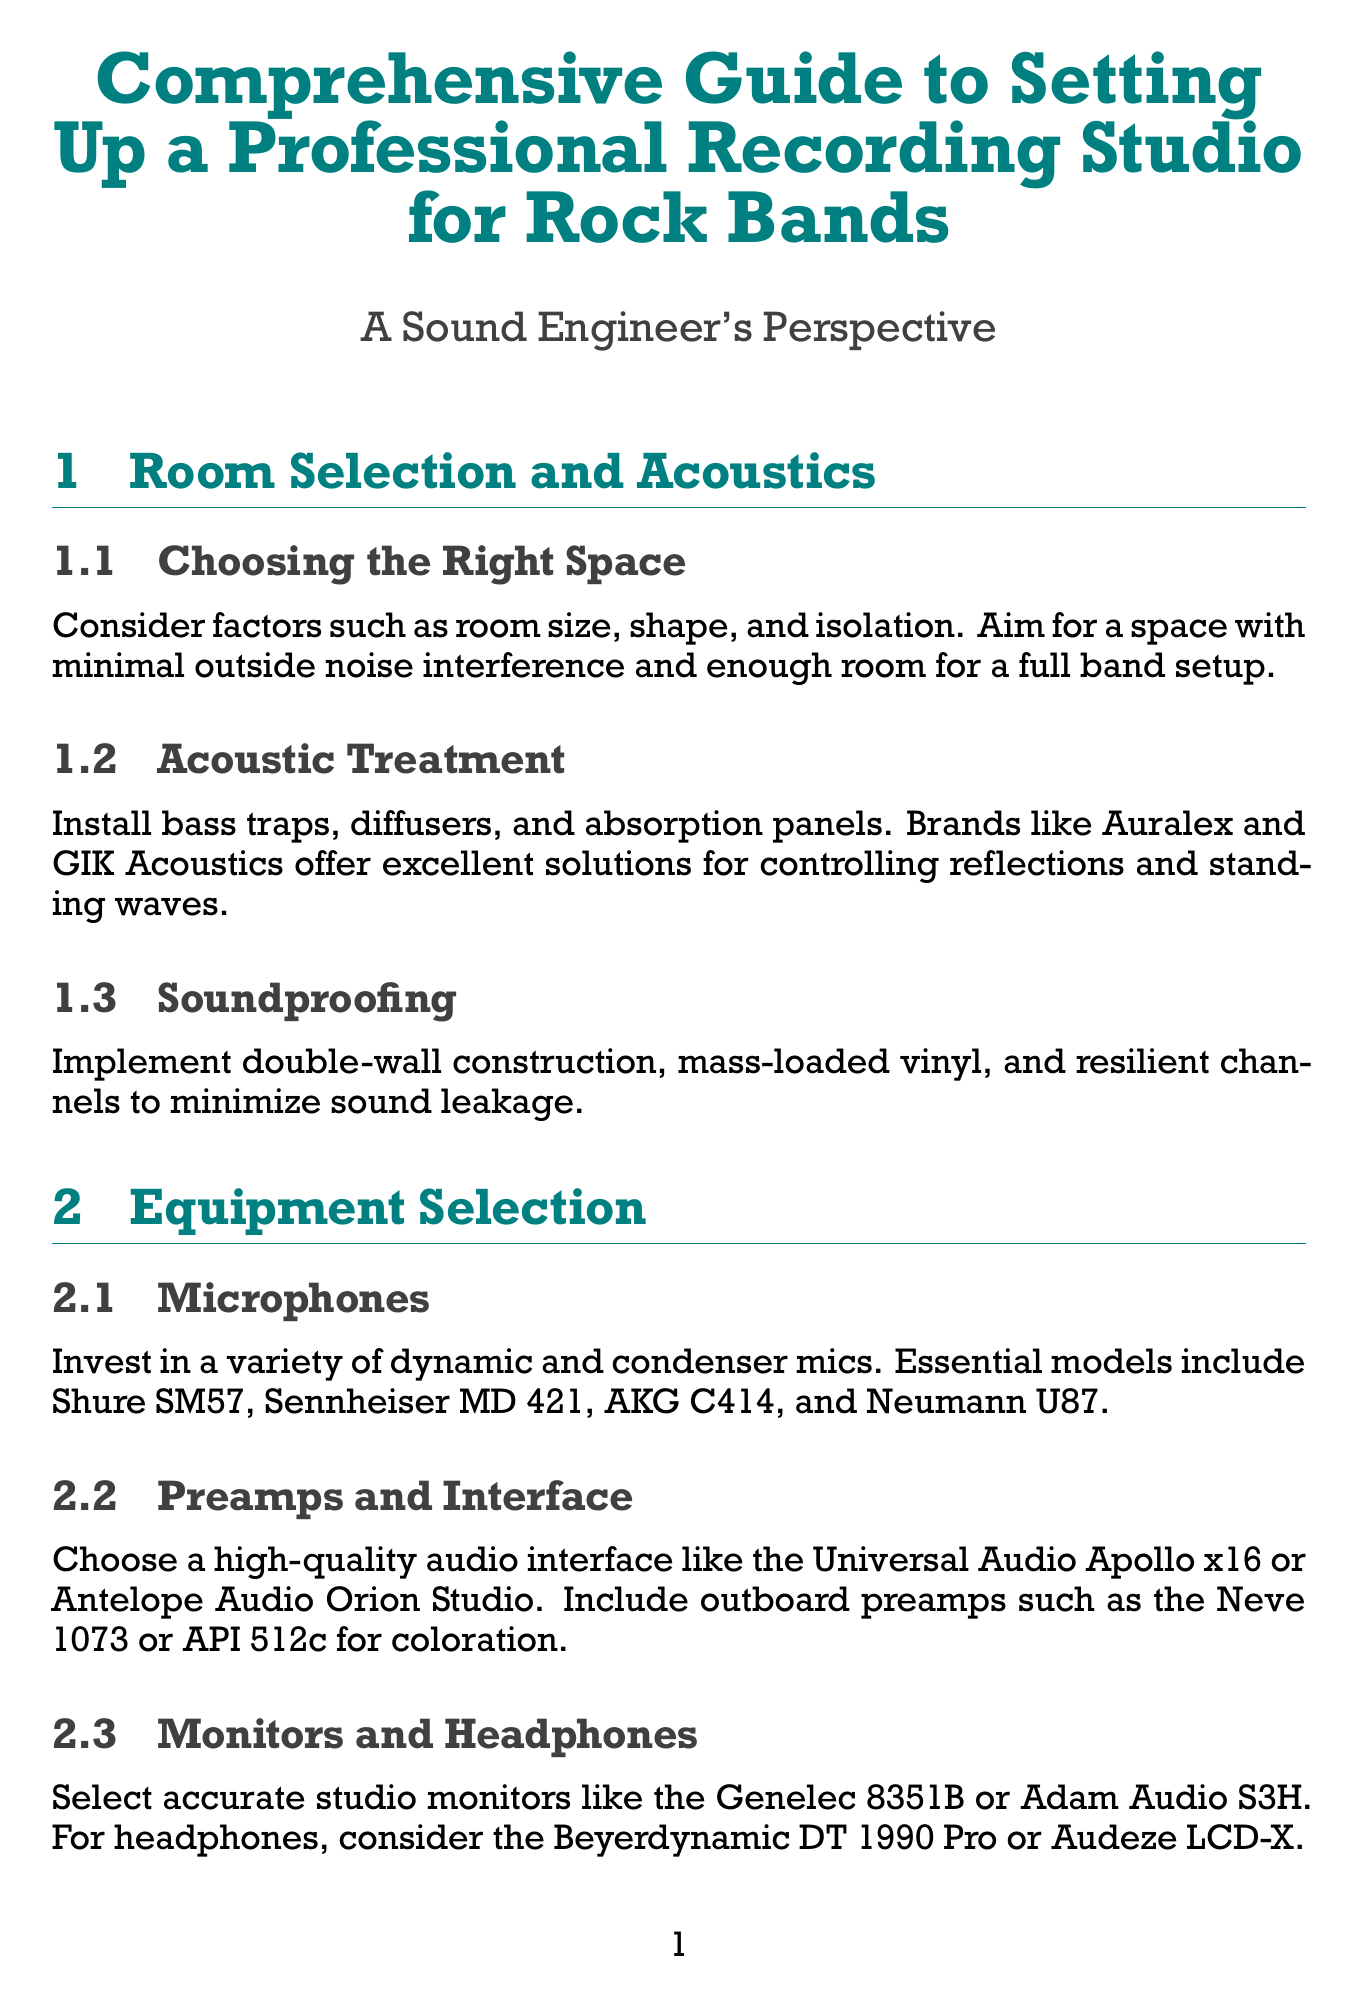What should be considered when choosing a recording space? The document mentions room size, shape, and isolation as key factors to consider for a recording space.
Answer: Room size, shape, and isolation Which microphones are essential for recording? The document lists essential microphones as Shure SM57, Sennheiser MD 421, AKG C414, and Neumann U87.
Answer: Shure SM57, Sennheiser MD 421, AKG C414, Neumann U87 What is recommended for acoustic treatment? The document advises installing bass traps, diffusers, and absorption panels for acoustic treatment.
Answer: Bass traps, diffusers, absorption panels Which DAWs are suggested for recording and editing? The document suggests Pro Tools, Logic Pro X, and Ableton Live as professional DAWs for recording and editing.
Answer: Pro Tools, Logic Pro X, Ableton Live What type of analog equipment is mentioned for achieving rock sound? The document references tape machines, analog compressors, and guitar and bass amplifiers for achieving rock sound.
Answer: Tape machines, analog compressors, guitar and bass amplifiers How can sound leakage be minimized? The document recommends implementing double-wall construction, mass-loaded vinyl, and resilient channels to minimize sound leakage.
Answer: Double-wall construction, mass-loaded vinyl, resilient channels What vinyl playback system is suggested? The document mentions setting up a high-end turntable like the Technics SL-1200G for vinyl playback.
Answer: Technics SL-1200G What is the purpose of gobos and baffles in the live room setup? The document states that gobos and baffles are included for isolation in the live room setup.
Answer: Isolation Which tool is recommended for room calibration? The document recommends using Sonarworks Reference 4 for room calibration.
Answer: Sonarworks Reference 4 